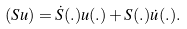Convert formula to latex. <formula><loc_0><loc_0><loc_500><loc_500>( S u ) = \dot { S } ( . ) u ( . ) + S ( . ) \dot { u } ( . ) .</formula> 